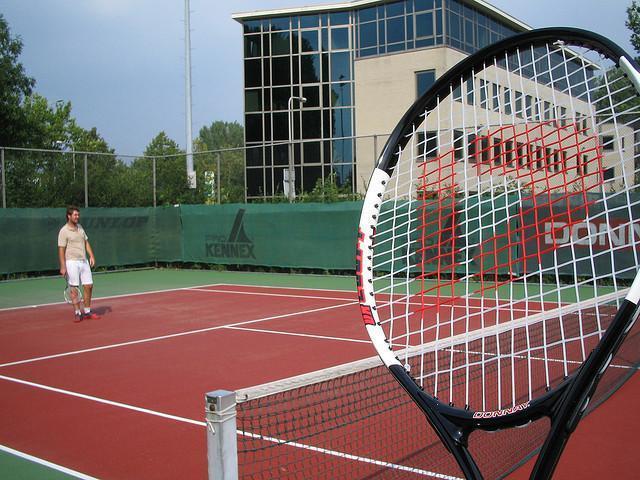How many tennis rackets are visible?
Give a very brief answer. 1. 